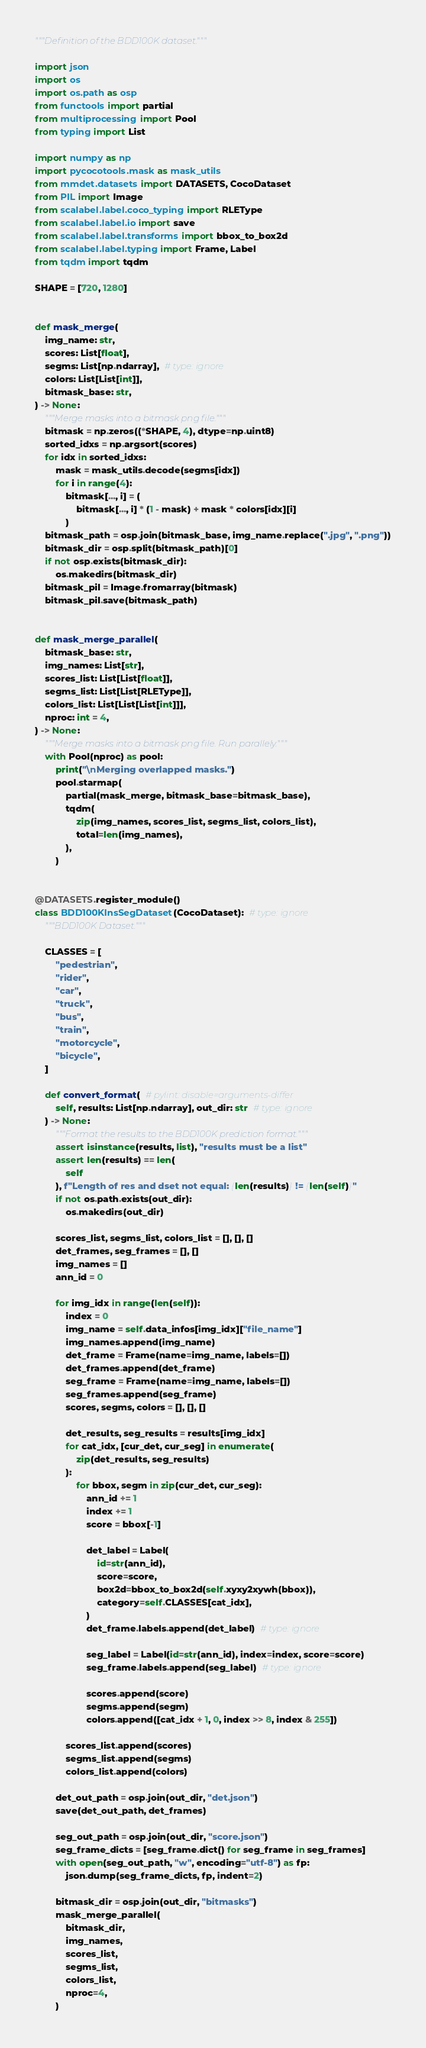Convert code to text. <code><loc_0><loc_0><loc_500><loc_500><_Python_>"""Definition of the BDD100K dataset."""

import json
import os
import os.path as osp
from functools import partial
from multiprocessing import Pool
from typing import List

import numpy as np
import pycocotools.mask as mask_utils
from mmdet.datasets import DATASETS, CocoDataset
from PIL import Image
from scalabel.label.coco_typing import RLEType
from scalabel.label.io import save
from scalabel.label.transforms import bbox_to_box2d
from scalabel.label.typing import Frame, Label
from tqdm import tqdm

SHAPE = [720, 1280]


def mask_merge(
    img_name: str,
    scores: List[float],
    segms: List[np.ndarray],  # type: ignore
    colors: List[List[int]],
    bitmask_base: str,
) -> None:
    """Merge masks into a bitmask png file."""
    bitmask = np.zeros((*SHAPE, 4), dtype=np.uint8)
    sorted_idxs = np.argsort(scores)
    for idx in sorted_idxs:
        mask = mask_utils.decode(segms[idx])
        for i in range(4):
            bitmask[..., i] = (
                bitmask[..., i] * (1 - mask) + mask * colors[idx][i]
            )
    bitmask_path = osp.join(bitmask_base, img_name.replace(".jpg", ".png"))
    bitmask_dir = osp.split(bitmask_path)[0]
    if not osp.exists(bitmask_dir):
        os.makedirs(bitmask_dir)
    bitmask_pil = Image.fromarray(bitmask)
    bitmask_pil.save(bitmask_path)


def mask_merge_parallel(
    bitmask_base: str,
    img_names: List[str],
    scores_list: List[List[float]],
    segms_list: List[List[RLEType]],
    colors_list: List[List[List[int]]],
    nproc: int = 4,
) -> None:
    """Merge masks into a bitmask png file. Run parallely."""
    with Pool(nproc) as pool:
        print("\nMerging overlapped masks.")
        pool.starmap(
            partial(mask_merge, bitmask_base=bitmask_base),
            tqdm(
                zip(img_names, scores_list, segms_list, colors_list),
                total=len(img_names),
            ),
        )


@DATASETS.register_module()
class BDD100KInsSegDataset(CocoDataset):  # type: ignore
    """BDD100K Dataset."""

    CLASSES = [
        "pedestrian",
        "rider",
        "car",
        "truck",
        "bus",
        "train",
        "motorcycle",
        "bicycle",
    ]

    def convert_format(  # pylint: disable=arguments-differ
        self, results: List[np.ndarray], out_dir: str  # type: ignore
    ) -> None:
        """Format the results to the BDD100K prediction format."""
        assert isinstance(results, list), "results must be a list"
        assert len(results) == len(
            self
        ), f"Length of res and dset not equal: {len(results)} != {len(self)}"
        if not os.path.exists(out_dir):
            os.makedirs(out_dir)

        scores_list, segms_list, colors_list = [], [], []
        det_frames, seg_frames = [], []
        img_names = []
        ann_id = 0

        for img_idx in range(len(self)):
            index = 0
            img_name = self.data_infos[img_idx]["file_name"]
            img_names.append(img_name)
            det_frame = Frame(name=img_name, labels=[])
            det_frames.append(det_frame)
            seg_frame = Frame(name=img_name, labels=[])
            seg_frames.append(seg_frame)
            scores, segms, colors = [], [], []

            det_results, seg_results = results[img_idx]
            for cat_idx, [cur_det, cur_seg] in enumerate(
                zip(det_results, seg_results)
            ):
                for bbox, segm in zip(cur_det, cur_seg):
                    ann_id += 1
                    index += 1
                    score = bbox[-1]

                    det_label = Label(
                        id=str(ann_id),
                        score=score,
                        box2d=bbox_to_box2d(self.xyxy2xywh(bbox)),
                        category=self.CLASSES[cat_idx],
                    )
                    det_frame.labels.append(det_label)  # type: ignore

                    seg_label = Label(id=str(ann_id), index=index, score=score)
                    seg_frame.labels.append(seg_label)  # type: ignore

                    scores.append(score)
                    segms.append(segm)
                    colors.append([cat_idx + 1, 0, index >> 8, index & 255])

            scores_list.append(scores)
            segms_list.append(segms)
            colors_list.append(colors)

        det_out_path = osp.join(out_dir, "det.json")
        save(det_out_path, det_frames)

        seg_out_path = osp.join(out_dir, "score.json")
        seg_frame_dicts = [seg_frame.dict() for seg_frame in seg_frames]
        with open(seg_out_path, "w", encoding="utf-8") as fp:
            json.dump(seg_frame_dicts, fp, indent=2)

        bitmask_dir = osp.join(out_dir, "bitmasks")
        mask_merge_parallel(
            bitmask_dir,
            img_names,
            scores_list,
            segms_list,
            colors_list,
            nproc=4,
        )
</code> 